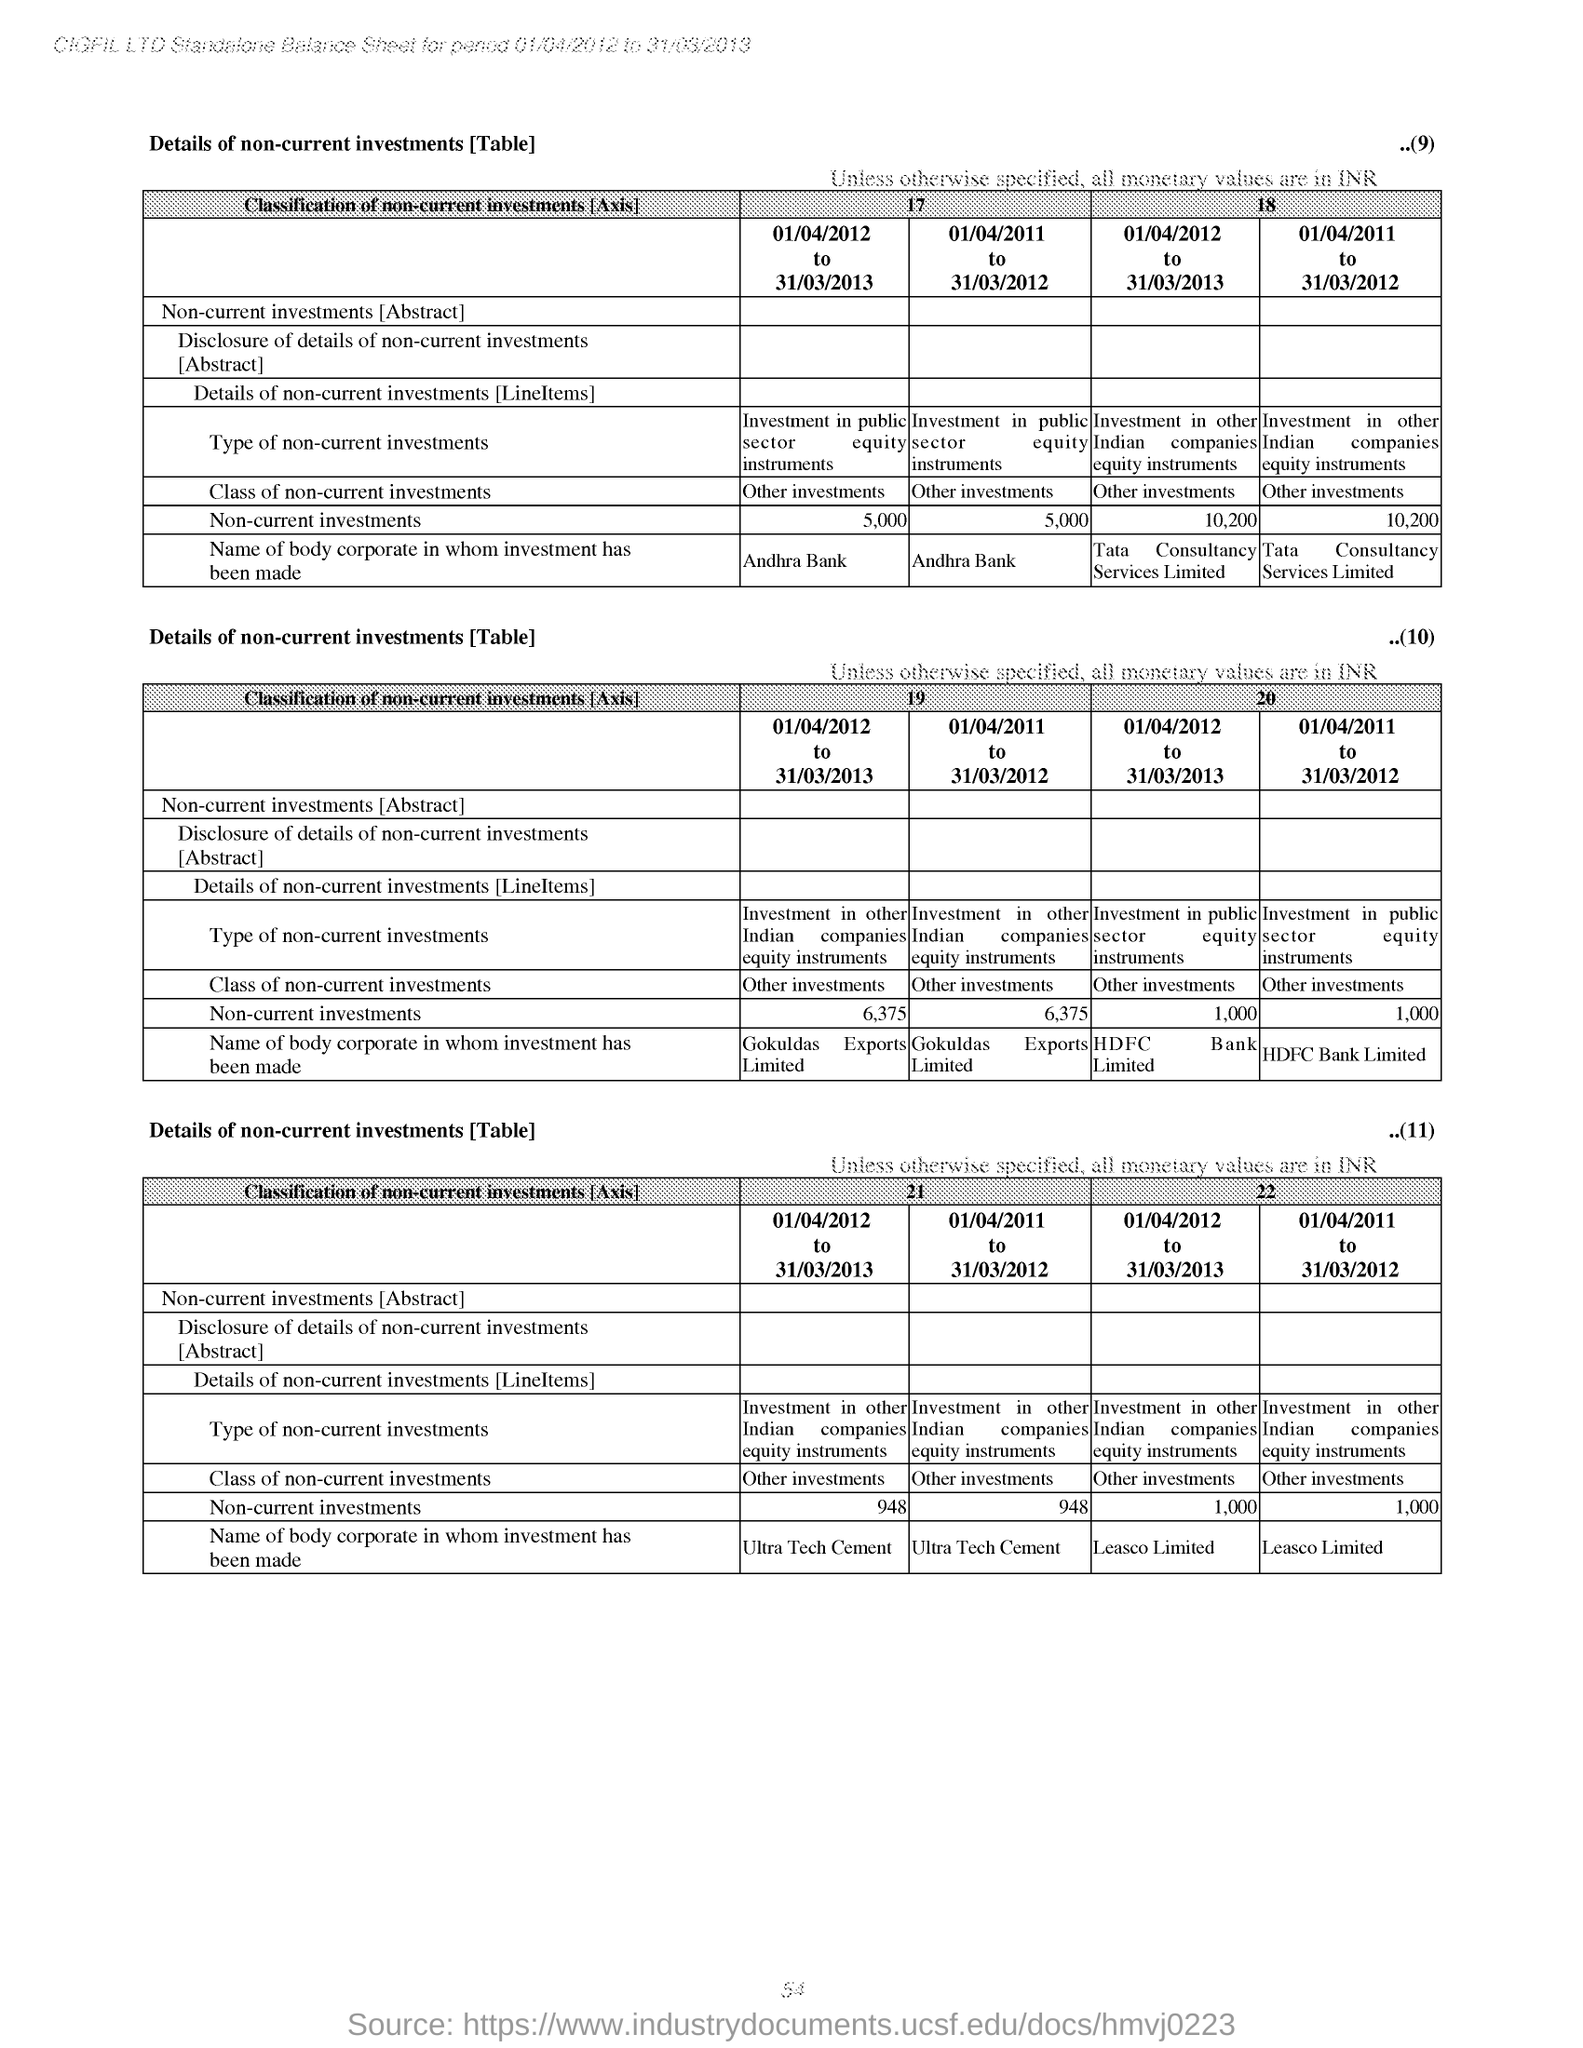Draw attention to some important aspects in this diagram. The page number is 54. 